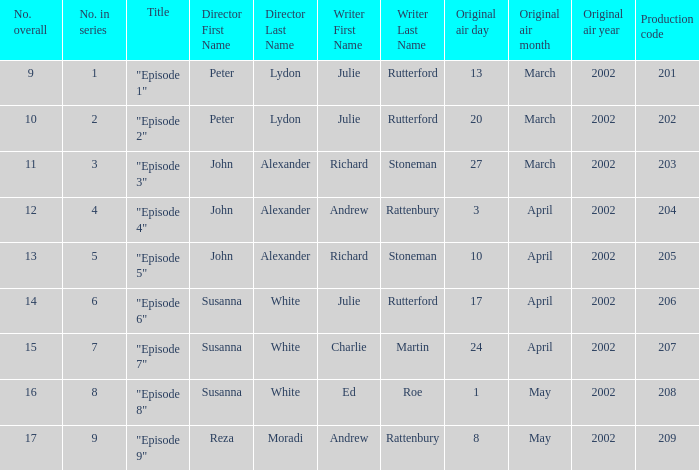When 1 is the numeral in order, who is the director? Peter Lydon. 